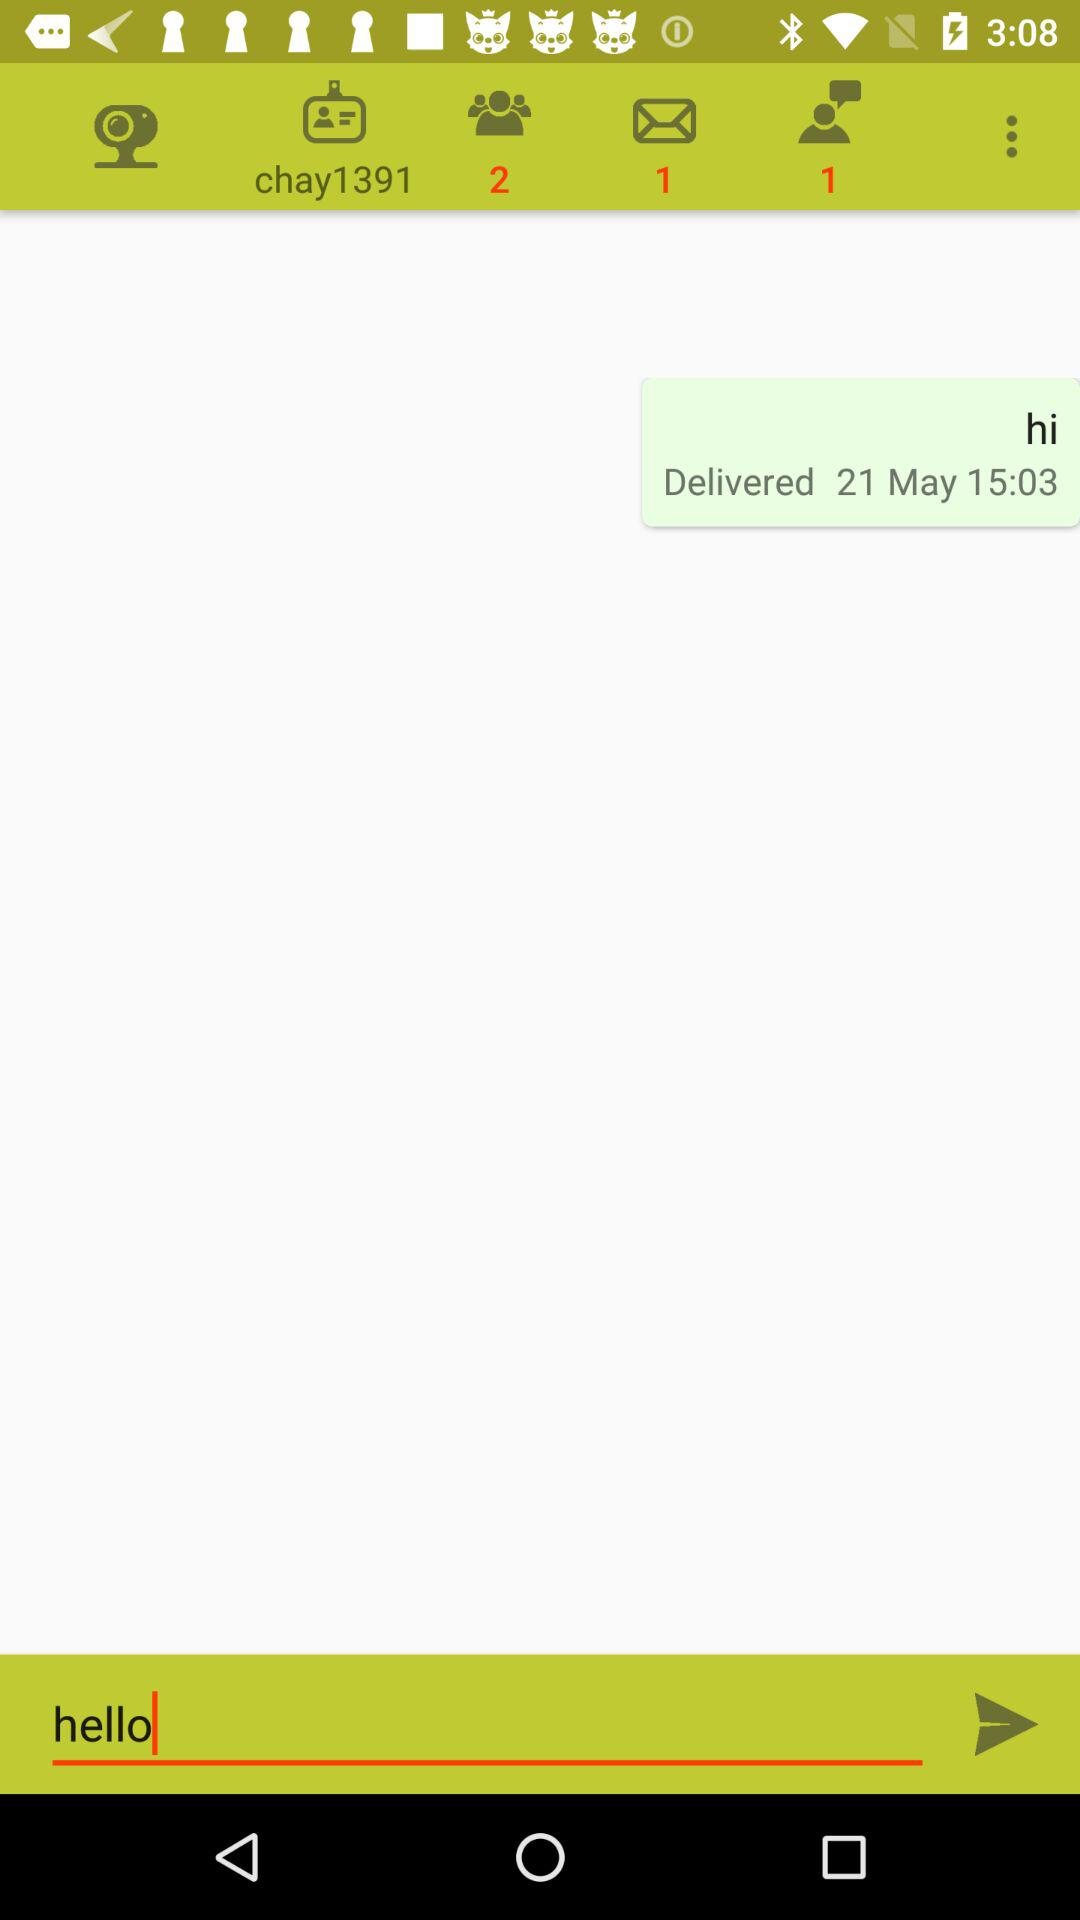What message was sent? The sent message was "hi". 